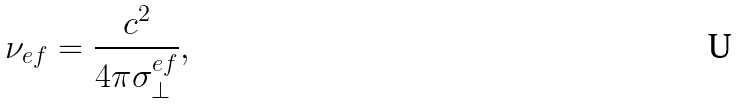Convert formula to latex. <formula><loc_0><loc_0><loc_500><loc_500>\nu _ { e f } = \frac { c ^ { 2 } } { 4 \pi \sigma _ { \perp } ^ { e f } } ,</formula> 